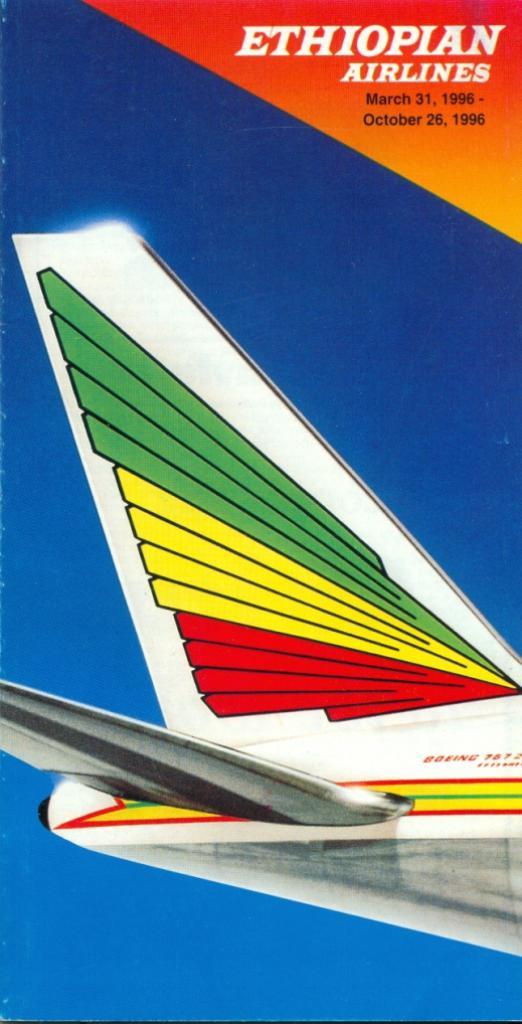What airline is this poster for?
Your answer should be very brief. Ethiopian airlines. What airlines is being shown?
Ensure brevity in your answer.  Ethiopian. 